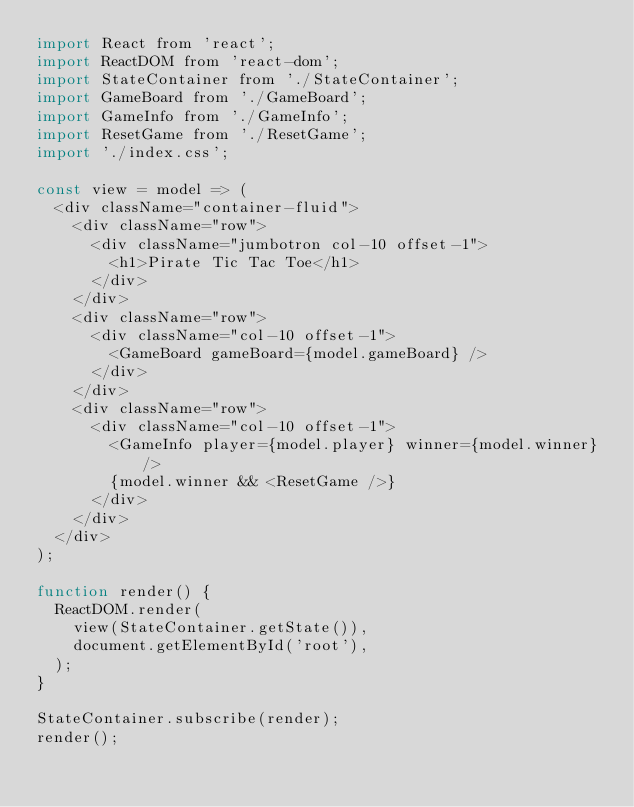<code> <loc_0><loc_0><loc_500><loc_500><_JavaScript_>import React from 'react';
import ReactDOM from 'react-dom';
import StateContainer from './StateContainer';
import GameBoard from './GameBoard';
import GameInfo from './GameInfo';
import ResetGame from './ResetGame';
import './index.css';

const view = model => (
  <div className="container-fluid">
    <div className="row">
      <div className="jumbotron col-10 offset-1">
        <h1>Pirate Tic Tac Toe</h1>
      </div>
    </div>
    <div className="row">
      <div className="col-10 offset-1">
        <GameBoard gameBoard={model.gameBoard} />
      </div>
    </div>
    <div className="row">
      <div className="col-10 offset-1">
        <GameInfo player={model.player} winner={model.winner} />
        {model.winner && <ResetGame />}
      </div>
    </div>
  </div>
);

function render() {
  ReactDOM.render(
    view(StateContainer.getState()),
    document.getElementById('root'),
  );
}

StateContainer.subscribe(render);
render();
</code> 